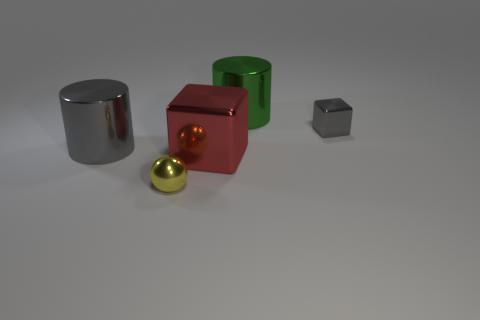What number of other things are there of the same color as the tiny cube?
Ensure brevity in your answer.  1. The yellow metal object is what shape?
Provide a short and direct response. Sphere. The metallic cylinder that is right of the metal thing that is left of the tiny yellow metal object is what color?
Your answer should be compact. Green. There is a big metallic block; is its color the same as the large cylinder that is right of the small shiny sphere?
Your answer should be very brief. No. What material is the thing that is both right of the small shiny sphere and in front of the small cube?
Offer a terse response. Metal. Is there a brown shiny sphere that has the same size as the red thing?
Your response must be concise. No. There is a gray cylinder that is the same size as the green cylinder; what is it made of?
Your answer should be compact. Metal. There is a small metal block; how many green metal things are on the left side of it?
Make the answer very short. 1. Is the shape of the big red thing on the right side of the yellow metallic sphere the same as  the large green thing?
Offer a terse response. No. Are there any big gray objects that have the same shape as the big red metal object?
Provide a succinct answer. No. 